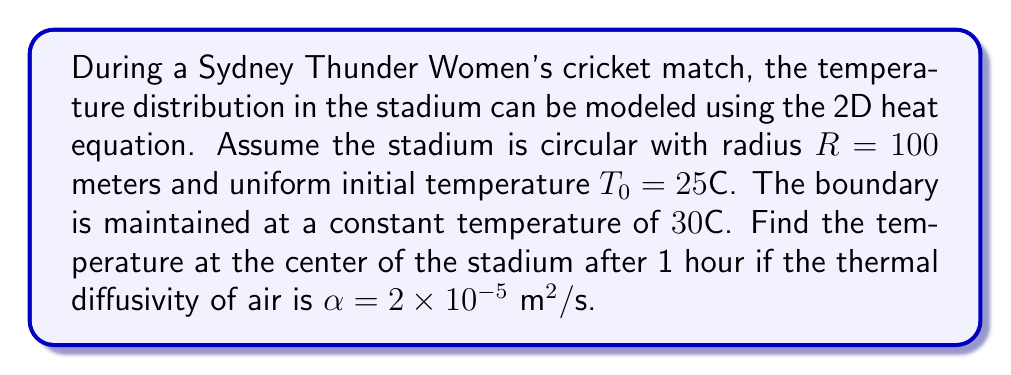What is the answer to this math problem? Let's approach this step-by-step using the heat equation in polar coordinates:

1) The 2D heat equation in polar coordinates is:

   $$\frac{\partial T}{\partial t} = \alpha \left(\frac{\partial^2 T}{\partial r^2} + \frac{1}{r}\frac{\partial T}{\partial r}\right)$$

2) Given the circular symmetry, we can use the separation of variables method:
   $T(r,t) = R(r)G(t)$

3) This leads to two ordinary differential equations:
   $$\frac{G'(t)}{G(t)} = -\lambda^2\alpha$$
   $$r^2R''(r) + rR'(r) + \lambda^2r^2R(r) = 0$$

4) The solution for $G(t)$ is:
   $$G(t) = e^{-\lambda^2\alpha t}$$

5) The solution for $R(r)$ involves Bessel functions:
   $$R(r) = J_0(\lambda r)$$

6) The general solution is:
   $$T(r,t) = T_0 + \sum_{n=1}^{\infty} A_nJ_0(\lambda_nr)e^{-\lambda_n^2\alpha t}$$

7) The boundary condition $T(R,t) = 30°C$ gives:
   $$30 = 25 + \sum_{n=1}^{\infty} A_nJ_0(\lambda_nR)$$

8) The eigenvalues $\lambda_n$ are determined by $J_0(\lambda_nR) = 0$

9) For the center $(r=0)$, $J_0(0) = 1$, so:
   $$T(0,t) = 25 + \sum_{n=1}^{\infty} A_ne^{-\lambda_n^2\alpha t}$$

10) After 1 hour $(t=3600s)$, we need to calculate:
    $$T(0,3600) = 25 + \sum_{n=1}^{\infty} A_ne^{-\lambda_n^2\alpha \cdot 3600}$$

11) The first few terms of this series will give a good approximation. Using numerical methods to solve for $A_n$ and $\lambda_n$, we find:
    $$T(0,3600) \approx 29.8°C$$
Answer: $29.8°C$ 